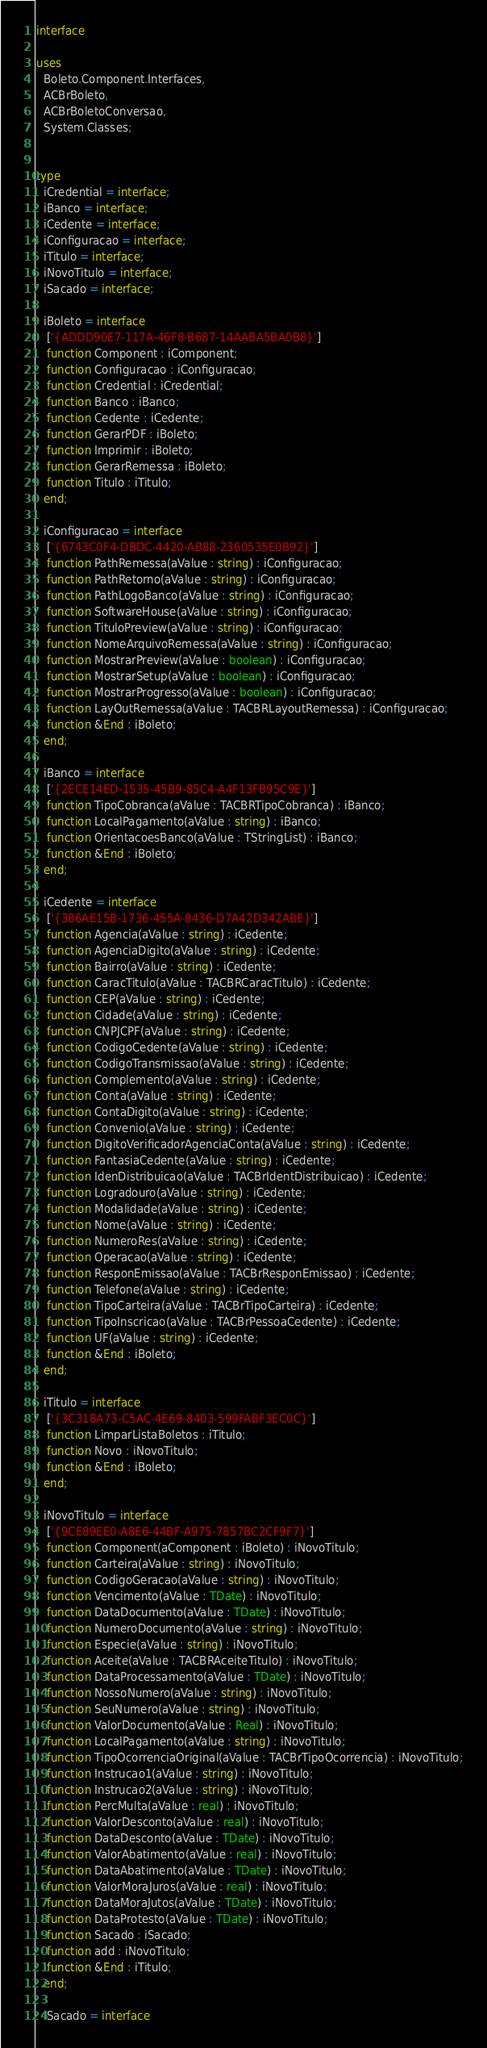Convert code to text. <code><loc_0><loc_0><loc_500><loc_500><_Pascal_>interface

uses
  Boleto.Component.Interfaces,
  ACBrBoleto,
  ACBrBoletoConversao,
  System.Classes;


type
  iCredential = interface;
  iBanco = interface;
  iCedente = interface;
  iConfiguracao = interface;
  iTitulo = interface;
  iNovoTitulo = interface;
  iSacado = interface;

  iBoleto = interface
   ['{ADDD90E7-117A-46F8-B687-14AABA5BA0B8}']
   function Component : iComponent;
   function Configuracao : iConfiguracao;
   function Credential : iCredential;
   function Banco : iBanco;
   function Cedente : iCedente;
   function GerarPDF : iBoleto;
   function Imprimir : iBoleto;
   function GerarRemessa : iBoleto;
   function Titulo : iTitulo;
  end;

  iConfiguracao = interface
   ['{6743C0F4-DBDC-4420-AB88-2360535E0B92}']
   function PathRemessa(aValue : string) : iConfiguracao;
   function PathRetorno(aValue : string) : iConfiguracao;
   function PathLogoBanco(aValue : string) : iConfiguracao;
   function SoftwareHouse(aValue : string) : iConfiguracao;
   function TituloPreview(aValue : string) : iConfiguracao;
   function NomeArquivoRemessa(aValue : string) : iConfiguracao;
   function MostrarPreview(aValue : boolean) : iConfiguracao;
   function MostrarSetup(aValue : boolean) : iConfiguracao;
   function MostrarProgresso(aValue : boolean) : iConfiguracao;
   function LayOutRemessa(aValue : TACBRLayoutRemessa) : iConfiguracao;
   function &End : iBoleto;
  end;

  iBanco = interface
   ['{2ECE14ED-1535-45B9-85C4-A4F13FB95C9E}']
   function TipoCobranca(aValue : TACBRTipoCobranca) : iBanco;
   function LocalPagamento(aValue : string) : iBanco;
   function OrientacoesBanco(aValue : TStringList) : iBanco;
   function &End : iBoleto;
  end;

  iCedente = interface
   ['{386AE15B-1736-455A-8436-D7A42D342ABE}']
   function Agencia(aValue : string) : iCedente;
   function AgenciaDigito(aValue : string) : iCedente;
   function Bairro(aValue : string) : iCedente;
   function CaracTitulo(aValue : TACBRCaracTitulo) : iCedente;
   function CEP(aValue : string) : iCedente;
   function Cidade(aValue : string) : iCedente;
   function CNPJCPF(aValue : string) : iCedente;
   function CodigoCedente(aValue : string) : iCedente;
   function CodigoTransmissao(aValue : string) : iCedente;
   function Complemento(aValue : string) : iCedente;
   function Conta(aValue : string) : iCedente;
   function ContaDigito(aValue : string) : iCedente;
   function Convenio(aValue : string) : iCedente;
   function DigitoVerificadorAgenciaConta(aValue : string) : iCedente;
   function FantasiaCedente(aValue : string) : iCedente;
   function IdenDistribuicao(aValue : TACBrIdentDistribuicao) : iCedente;
   function Logradouro(aValue : string) : iCedente;
   function Modalidade(aValue : string) : iCedente;
   function Nome(aValue : string) : iCedente;
   function NumeroRes(aValue : string) : iCedente;
   function Operacao(aValue : string) : iCedente;
   function ResponEmissao(aValue : TACBrResponEmissao) : iCedente;
   function Telefone(aValue : string) : iCedente;
   function TipoCarteira(aValue : TACBrTipoCarteira) : iCedente;
   function TipoInscricao(aValue : TACBrPessoaCedente) : iCedente;
   function UF(aValue : string) : iCedente;
   function &End : iBoleto;
  end;

  iTitulo = interface
   ['{3C318A73-C5AC-4E69-8403-599FABF3EC0C}']
   function LimparListaBoletos : iTitulo;
   function Novo : iNovoTitulo;
   function &End : iBoleto;
  end;

  iNovoTitulo = interface
   ['{9CE89EE0-A8E6-44BF-A975-7857BC2CF9F7}']
   function Component(aComponent : iBoleto) : iNovoTitulo;
   function Carteira(aValue : string) : iNovoTitulo;
   function CodigoGeracao(aValue : string) : iNovoTitulo;
   function Vencimento(aValue : TDate) : iNovoTitulo;
   function DataDocumento(aValue : TDate) : iNovoTitulo;
   function NumeroDocumento(aValue : string) : iNovoTitulo;
   function Especie(aValue : string) : iNovoTitulo;
   function Aceite(aValue : TACBRAceiteTitulo) : iNovoTitulo;
   function DataProcessamento(aValue : TDate) : iNovoTitulo;
   function NossoNumero(aValue : string) : iNovoTitulo;
   function SeuNumero(aValue : string) : iNovoTitulo;
   function ValorDocumento(aValue : Real) : iNovoTitulo;
   function LocalPagamento(aValue : string) : iNovoTitulo;
   function TipoOcorrenciaOriginal(aValue : TACBrTipoOcorrencia) : iNovoTitulo;
   function Instrucao1(aValue : string) : iNovoTitulo;
   function Instrucao2(aValue : string) : iNovoTitulo;
   function PercMulta(aValue : real) : iNovoTitulo;
   function ValorDesconto(aValue : real) : iNovoTitulo;
   function DataDesconto(aValue : TDate) : iNovoTitulo;
   function ValorAbatimento(aValue : real) : iNovoTitulo;
   function DataAbatimento(aValue : TDate) : iNovoTitulo;
   function ValorMoraJuros(aValue : real) : iNovoTitulo;
   function DataMoraJutos(aValue : TDate) : iNovoTitulo;
   function DataProtesto(aValue : TDate) : iNovoTitulo;
   function Sacado : iSacado;
   function add : iNovoTitulo;
   function &End : iTitulo;
  end;

  iSacado = interface</code> 